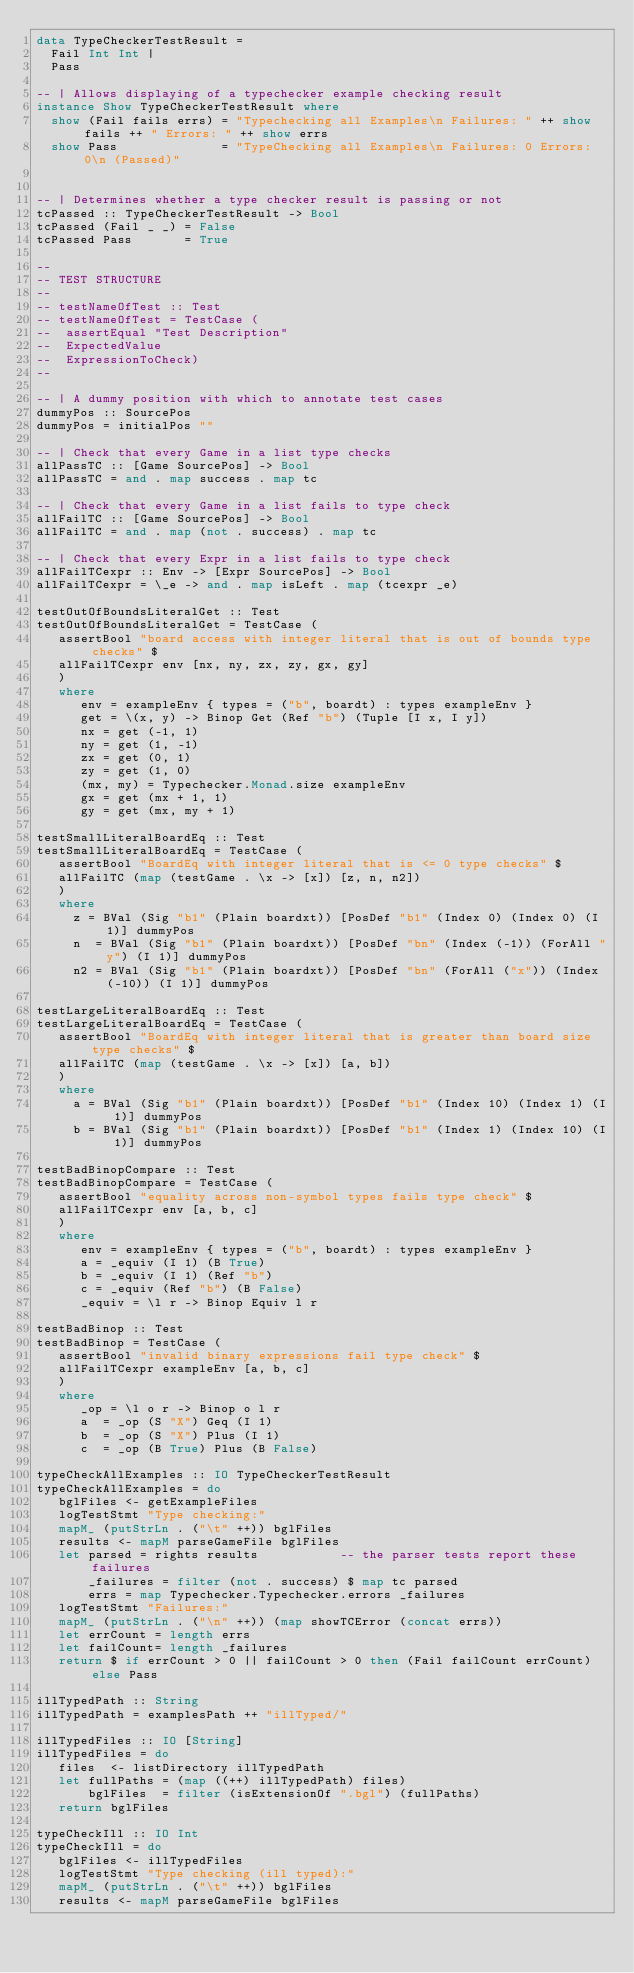<code> <loc_0><loc_0><loc_500><loc_500><_Haskell_>data TypeCheckerTestResult =
  Fail Int Int |
  Pass

-- | Allows displaying of a typechecker example checking result
instance Show TypeCheckerTestResult where
  show (Fail fails errs) = "Typechecking all Examples\n Failures: " ++ show fails ++ " Errors: " ++ show errs
  show Pass              = "TypeChecking all Examples\n Failures: 0 Errors: 0\n (Passed)"


-- | Determines whether a type checker result is passing or not
tcPassed :: TypeCheckerTestResult -> Bool
tcPassed (Fail _ _) = False
tcPassed Pass       = True

--
-- TEST STRUCTURE
--
-- testNameOfTest :: Test
-- testNameOfTest = TestCase (
--  assertEqual "Test Description"
--  ExpectedValue
--  ExpressionToCheck)
--

-- | A dummy position with which to annotate test cases
dummyPos :: SourcePos
dummyPos = initialPos ""

-- | Check that every Game in a list type checks
allPassTC :: [Game SourcePos] -> Bool
allPassTC = and . map success . map tc

-- | Check that every Game in a list fails to type check
allFailTC :: [Game SourcePos] -> Bool
allFailTC = and . map (not . success) . map tc

-- | Check that every Expr in a list fails to type check
allFailTCexpr :: Env -> [Expr SourcePos] -> Bool
allFailTCexpr = \_e -> and . map isLeft . map (tcexpr _e)

testOutOfBoundsLiteralGet :: Test
testOutOfBoundsLiteralGet = TestCase (
   assertBool "board access with integer literal that is out of bounds type checks" $
   allFailTCexpr env [nx, ny, zx, zy, gx, gy]
   )
   where
      env = exampleEnv { types = ("b", boardt) : types exampleEnv }
      get = \(x, y) -> Binop Get (Ref "b") (Tuple [I x, I y])
      nx = get (-1, 1)
      ny = get (1, -1)
      zx = get (0, 1)
      zy = get (1, 0)
      (mx, my) = Typechecker.Monad.size exampleEnv
      gx = get (mx + 1, 1)
      gy = get (mx, my + 1)

testSmallLiteralBoardEq :: Test
testSmallLiteralBoardEq = TestCase (
   assertBool "BoardEq with integer literal that is <= 0 type checks" $
   allFailTC (map (testGame . \x -> [x]) [z, n, n2])
   )
   where
     z = BVal (Sig "b1" (Plain boardxt)) [PosDef "b1" (Index 0) (Index 0) (I 1)] dummyPos
     n  = BVal (Sig "b1" (Plain boardxt)) [PosDef "bn" (Index (-1)) (ForAll "y") (I 1)] dummyPos
     n2 = BVal (Sig "b1" (Plain boardxt)) [PosDef "bn" (ForAll ("x")) (Index (-10)) (I 1)] dummyPos

testLargeLiteralBoardEq :: Test
testLargeLiteralBoardEq = TestCase (
   assertBool "BoardEq with integer literal that is greater than board size type checks" $
   allFailTC (map (testGame . \x -> [x]) [a, b])
   )
   where
     a = BVal (Sig "b1" (Plain boardxt)) [PosDef "b1" (Index 10) (Index 1) (I 1)] dummyPos
     b = BVal (Sig "b1" (Plain boardxt)) [PosDef "b1" (Index 1) (Index 10) (I 1)] dummyPos

testBadBinopCompare :: Test
testBadBinopCompare = TestCase (
   assertBool "equality across non-symbol types fails type check" $
   allFailTCexpr env [a, b, c]
   )
   where
      env = exampleEnv { types = ("b", boardt) : types exampleEnv }
      a = _equiv (I 1) (B True)
      b = _equiv (I 1) (Ref "b")
      c = _equiv (Ref "b") (B False)
      _equiv = \l r -> Binop Equiv l r

testBadBinop :: Test
testBadBinop = TestCase (
   assertBool "invalid binary expressions fail type check" $
   allFailTCexpr exampleEnv [a, b, c]
   )
   where
      _op = \l o r -> Binop o l r
      a  = _op (S "X") Geq (I 1)
      b  = _op (S "X") Plus (I 1)
      c  = _op (B True) Plus (B False)

typeCheckAllExamples :: IO TypeCheckerTestResult
typeCheckAllExamples = do
   bglFiles <- getExampleFiles
   logTestStmt "Type checking:"
   mapM_ (putStrLn . ("\t" ++)) bglFiles
   results <- mapM parseGameFile bglFiles
   let parsed = rights results           -- the parser tests report these failures
       _failures = filter (not . success) $ map tc parsed
       errs = map Typechecker.Typechecker.errors _failures
   logTestStmt "Failures:"
   mapM_ (putStrLn . ("\n" ++)) (map showTCError (concat errs))
   let errCount = length errs
   let failCount= length _failures
   return $ if errCount > 0 || failCount > 0 then (Fail failCount errCount) else Pass

illTypedPath :: String
illTypedPath = examplesPath ++ "illTyped/"

illTypedFiles :: IO [String]
illTypedFiles = do
   files  <- listDirectory illTypedPath
   let fullPaths = (map ((++) illTypedPath) files)
       bglFiles  = filter (isExtensionOf ".bgl") (fullPaths)
   return bglFiles

typeCheckIll :: IO Int
typeCheckIll = do
   bglFiles <- illTypedFiles
   logTestStmt "Type checking (ill typed):"
   mapM_ (putStrLn . ("\t" ++)) bglFiles
   results <- mapM parseGameFile bglFiles</code> 